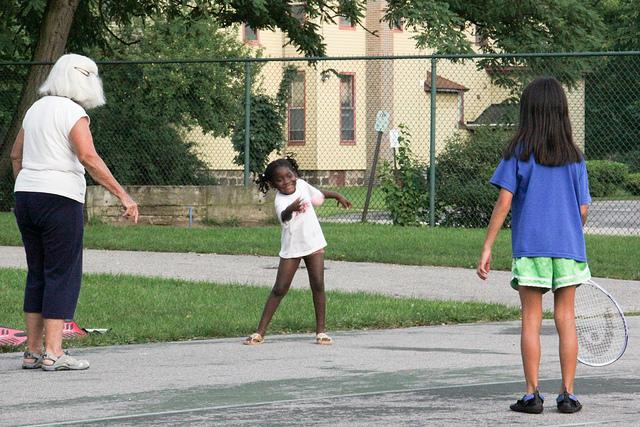What type of sporting area are girls most likely playing on? tennis court 